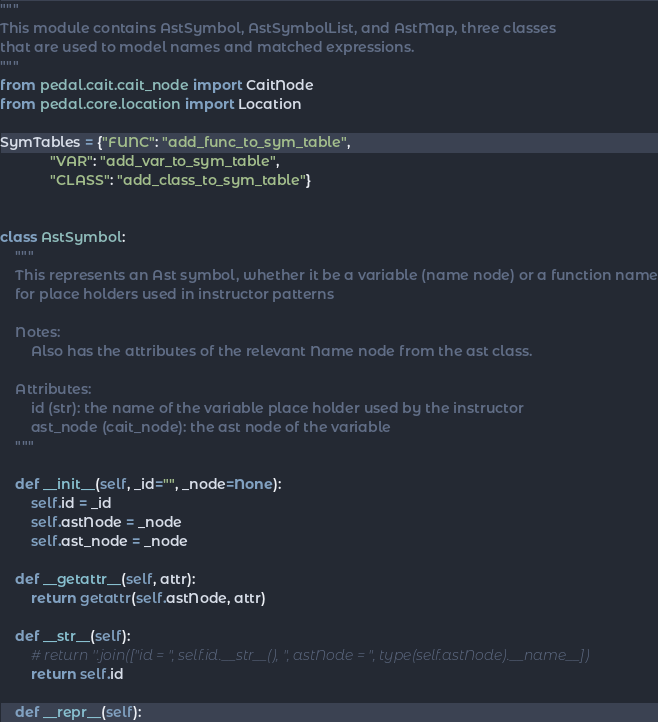<code> <loc_0><loc_0><loc_500><loc_500><_Python_>"""
This module contains AstSymbol, AstSymbolList, and AstMap, three classes
that are used to model names and matched expressions.
"""
from pedal.cait.cait_node import CaitNode
from pedal.core.location import Location

SymTables = {"FUNC": "add_func_to_sym_table",
             "VAR": "add_var_to_sym_table",
             "CLASS": "add_class_to_sym_table"}


class AstSymbol:
    """
    This represents an Ast symbol, whether it be a variable (name node) or a function name
    for place holders used in instructor patterns

    Notes:
        Also has the attributes of the relevant Name node from the ast class.

    Attributes:
        id (str): the name of the variable place holder used by the instructor
        ast_node (cait_node): the ast node of the variable
    """

    def __init__(self, _id="", _node=None):
        self.id = _id
        self.astNode = _node
        self.ast_node = _node

    def __getattr__(self, attr):
        return getattr(self.astNode, attr)

    def __str__(self):
        # return ''.join(["id = ", self.id.__str__(), ", astNode = ", type(self.astNode).__name__])
        return self.id

    def __repr__(self):</code> 